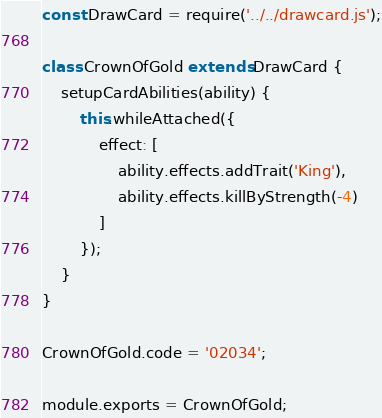<code> <loc_0><loc_0><loc_500><loc_500><_JavaScript_>const DrawCard = require('../../drawcard.js');

class CrownOfGold extends DrawCard {
    setupCardAbilities(ability) {
        this.whileAttached({
            effect: [
                ability.effects.addTrait('King'),
                ability.effects.killByStrength(-4)
            ]
        });
    }
}

CrownOfGold.code = '02034';

module.exports = CrownOfGold;
</code> 